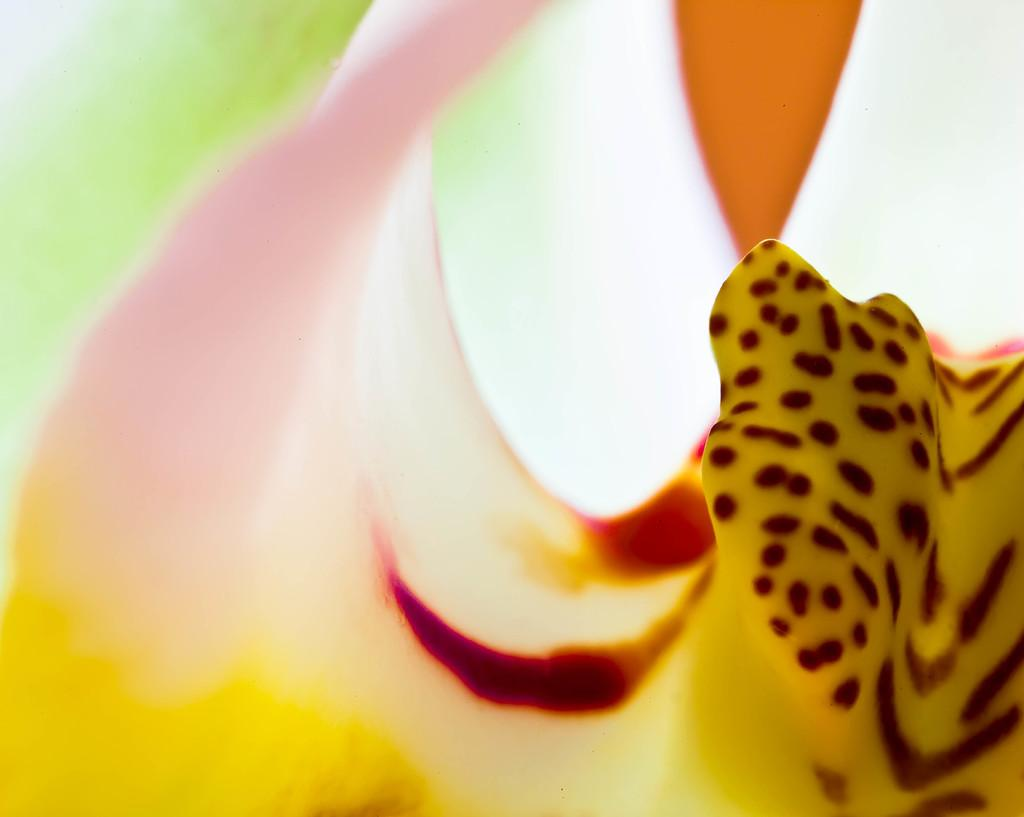What is the main focus of the image? The image has a close-up view of an object. Can you describe the object in the image? The object in the image has a painting on it. What type of skirt is visible in the image? There is no skirt present in the image; it features a close-up view of an object with a painting on it. What type of vessel is used to hold the object in the image? There is no vessel present in the image; it is a close-up view of the object itself. 